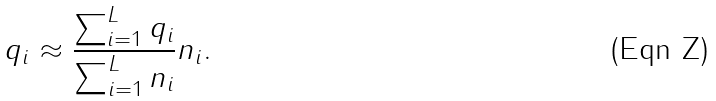Convert formula to latex. <formula><loc_0><loc_0><loc_500><loc_500>q _ { i } \approx \frac { \sum _ { i = 1 } ^ { L } q _ { i } } { \sum _ { i = 1 } ^ { L } n _ { i } } n _ { i } .</formula> 